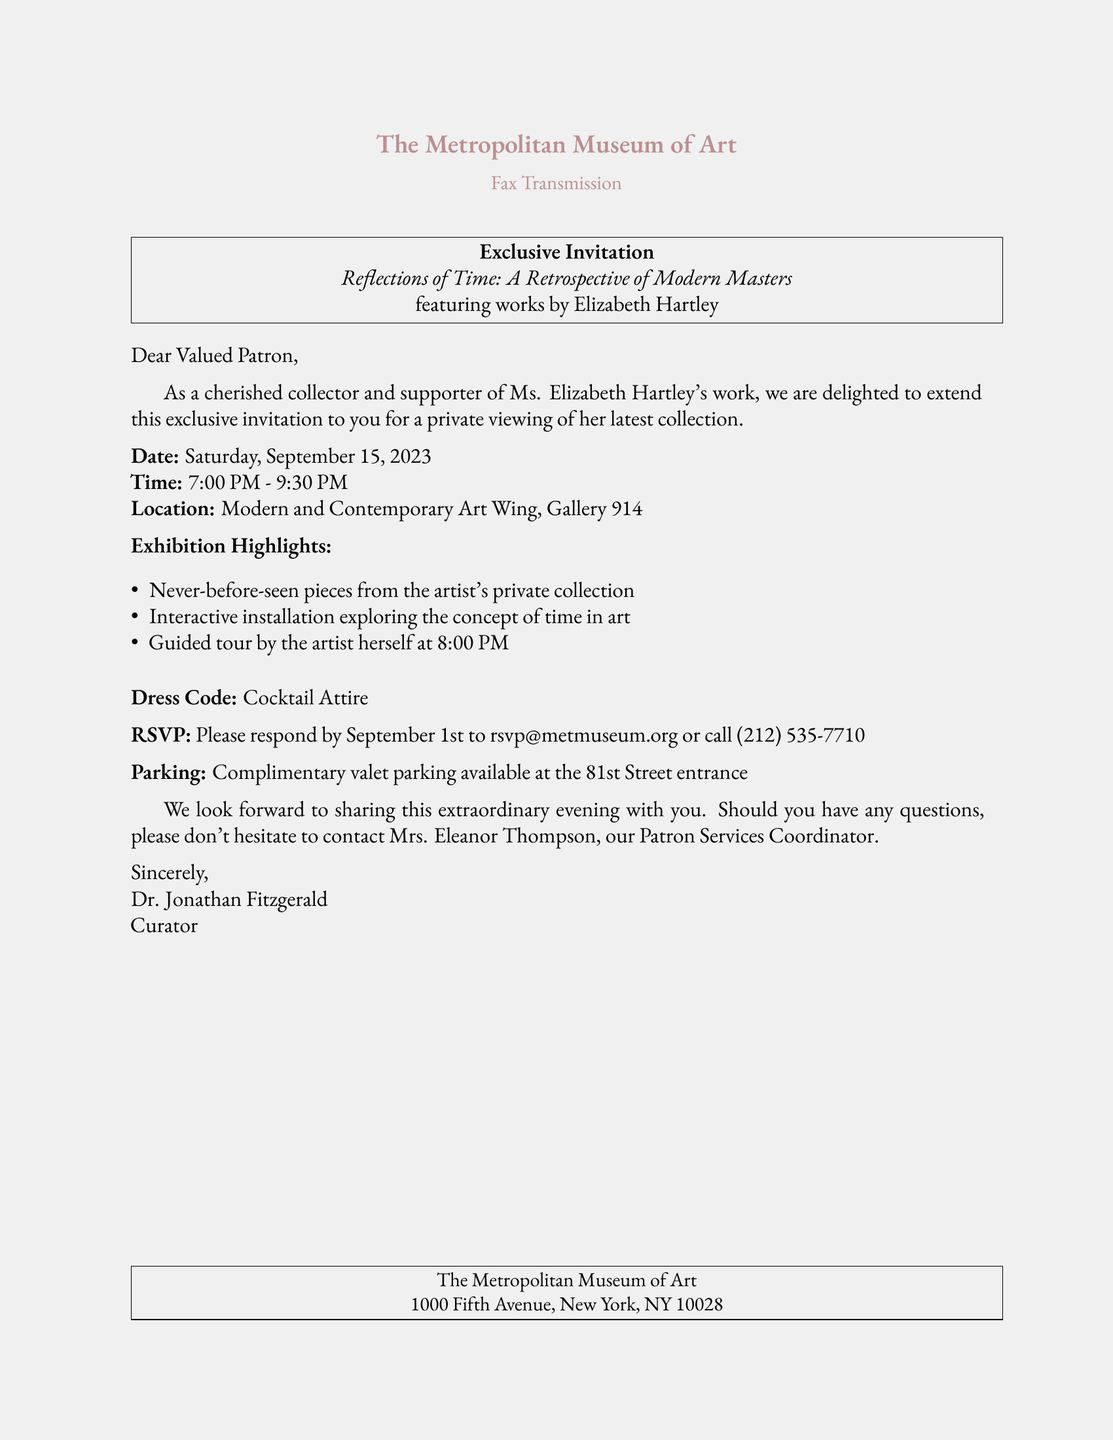What is the title of the exhibition? The title is specifically mentioned in the document and is "Reflections of Time: A Retrospective of Modern Masters."
Answer: Reflections of Time: A Retrospective of Modern Masters Who is the featured artist? The document specifies that the featured artist is Elizabeth Hartley.
Answer: Elizabeth Hartley What is the date of the private viewing? The document lists the date of the event as Saturday, September 15, 2023.
Answer: September 15, 2023 What time does the event start? The start time of the event is clearly stated in the document as 7:00 PM.
Answer: 7:00 PM What is the dress code for the event? The dress code is explicitly mentioned in the document, indicating formal attire expectations.
Answer: Cocktail Attire What guided feature will be available during the exhibition? The document states there will be a guided tour by the artist herself at 8:00 PM, presenting special insights.
Answer: Guided tour by the artist When is the RSVP deadline? The RSVP deadline is provided in the document and can be logically inferred from the date listed for the event.
Answer: September 1st What is offered for parking? The document outlines the parking arrangements and indicates what is available for guests at the venue.
Answer: Complimentary valet parking Who is the contact person for questions? The document provides the name of the individual responsible for assisting patrons, which is essential for inquiries.
Answer: Mrs. Eleanor Thompson 